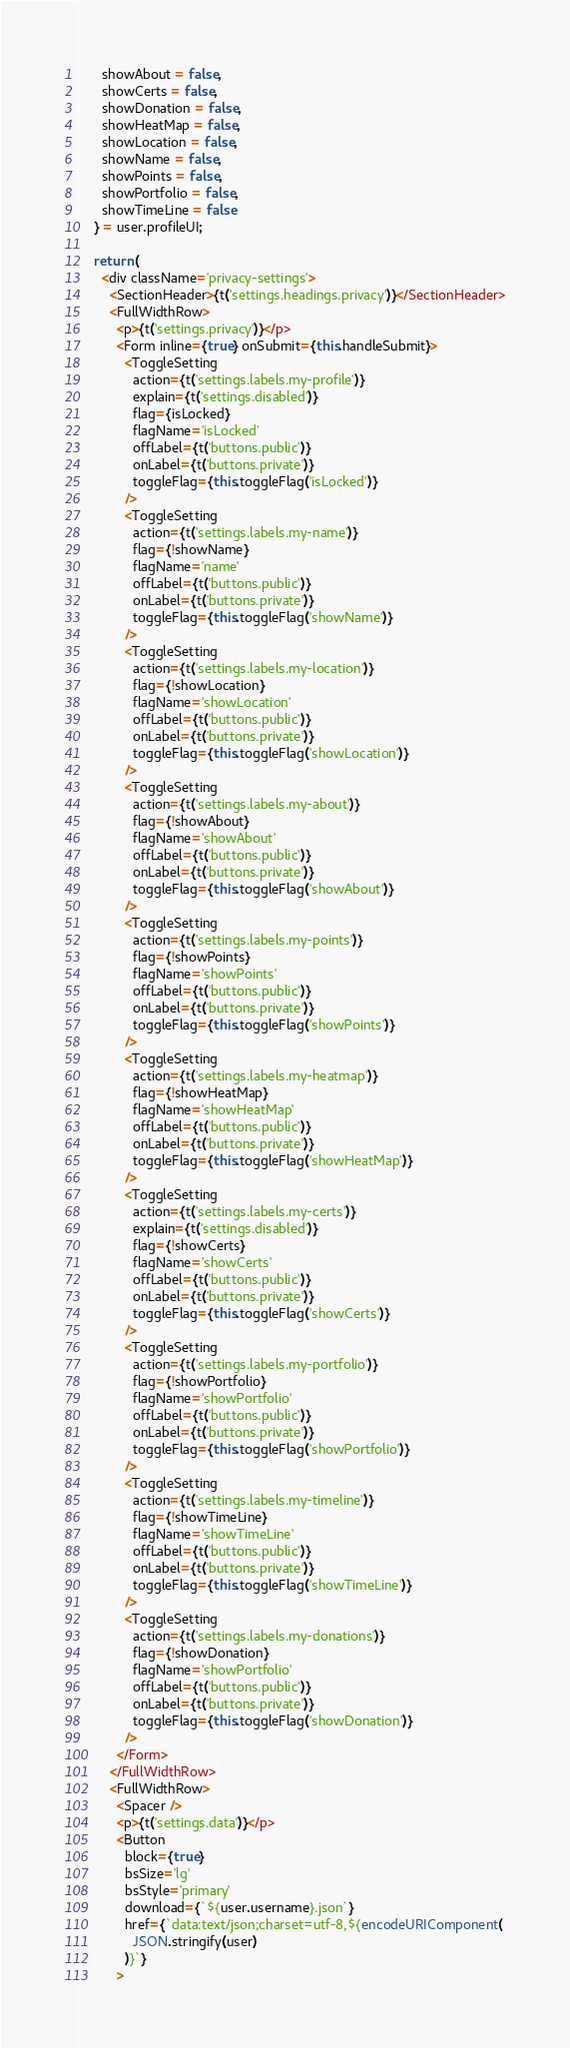Convert code to text. <code><loc_0><loc_0><loc_500><loc_500><_JavaScript_>      showAbout = false,
      showCerts = false,
      showDonation = false,
      showHeatMap = false,
      showLocation = false,
      showName = false,
      showPoints = false,
      showPortfolio = false,
      showTimeLine = false
    } = user.profileUI;

    return (
      <div className='privacy-settings'>
        <SectionHeader>{t('settings.headings.privacy')}</SectionHeader>
        <FullWidthRow>
          <p>{t('settings.privacy')}</p>
          <Form inline={true} onSubmit={this.handleSubmit}>
            <ToggleSetting
              action={t('settings.labels.my-profile')}
              explain={t('settings.disabled')}
              flag={isLocked}
              flagName='isLocked'
              offLabel={t('buttons.public')}
              onLabel={t('buttons.private')}
              toggleFlag={this.toggleFlag('isLocked')}
            />
            <ToggleSetting
              action={t('settings.labels.my-name')}
              flag={!showName}
              flagName='name'
              offLabel={t('buttons.public')}
              onLabel={t('buttons.private')}
              toggleFlag={this.toggleFlag('showName')}
            />
            <ToggleSetting
              action={t('settings.labels.my-location')}
              flag={!showLocation}
              flagName='showLocation'
              offLabel={t('buttons.public')}
              onLabel={t('buttons.private')}
              toggleFlag={this.toggleFlag('showLocation')}
            />
            <ToggleSetting
              action={t('settings.labels.my-about')}
              flag={!showAbout}
              flagName='showAbout'
              offLabel={t('buttons.public')}
              onLabel={t('buttons.private')}
              toggleFlag={this.toggleFlag('showAbout')}
            />
            <ToggleSetting
              action={t('settings.labels.my-points')}
              flag={!showPoints}
              flagName='showPoints'
              offLabel={t('buttons.public')}
              onLabel={t('buttons.private')}
              toggleFlag={this.toggleFlag('showPoints')}
            />
            <ToggleSetting
              action={t('settings.labels.my-heatmap')}
              flag={!showHeatMap}
              flagName='showHeatMap'
              offLabel={t('buttons.public')}
              onLabel={t('buttons.private')}
              toggleFlag={this.toggleFlag('showHeatMap')}
            />
            <ToggleSetting
              action={t('settings.labels.my-certs')}
              explain={t('settings.disabled')}
              flag={!showCerts}
              flagName='showCerts'
              offLabel={t('buttons.public')}
              onLabel={t('buttons.private')}
              toggleFlag={this.toggleFlag('showCerts')}
            />
            <ToggleSetting
              action={t('settings.labels.my-portfolio')}
              flag={!showPortfolio}
              flagName='showPortfolio'
              offLabel={t('buttons.public')}
              onLabel={t('buttons.private')}
              toggleFlag={this.toggleFlag('showPortfolio')}
            />
            <ToggleSetting
              action={t('settings.labels.my-timeline')}
              flag={!showTimeLine}
              flagName='showTimeLine'
              offLabel={t('buttons.public')}
              onLabel={t('buttons.private')}
              toggleFlag={this.toggleFlag('showTimeLine')}
            />
            <ToggleSetting
              action={t('settings.labels.my-donations')}
              flag={!showDonation}
              flagName='showPortfolio'
              offLabel={t('buttons.public')}
              onLabel={t('buttons.private')}
              toggleFlag={this.toggleFlag('showDonation')}
            />
          </Form>
        </FullWidthRow>
        <FullWidthRow>
          <Spacer />
          <p>{t('settings.data')}</p>
          <Button
            block={true}
            bsSize='lg'
            bsStyle='primary'
            download={`${user.username}.json`}
            href={`data:text/json;charset=utf-8,${encodeURIComponent(
              JSON.stringify(user)
            )}`}
          ></code> 